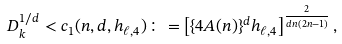<formula> <loc_0><loc_0><loc_500><loc_500>D _ { k } ^ { 1 / d } < c _ { 1 } ( n , d , h _ { \ell , 4 } ) \colon = \left [ \{ 4 A ( n ) \} ^ { d } h _ { \ell , 4 } \right ] ^ { \frac { 2 } { d n ( 2 n - 1 ) } } ,</formula> 